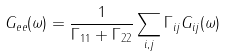Convert formula to latex. <formula><loc_0><loc_0><loc_500><loc_500>G _ { e e } ( \omega ) = \frac { 1 } { \Gamma _ { 1 1 } + \Gamma _ { 2 2 } } \sum _ { i , j } \Gamma _ { i j } G _ { i j } ( \omega )</formula> 